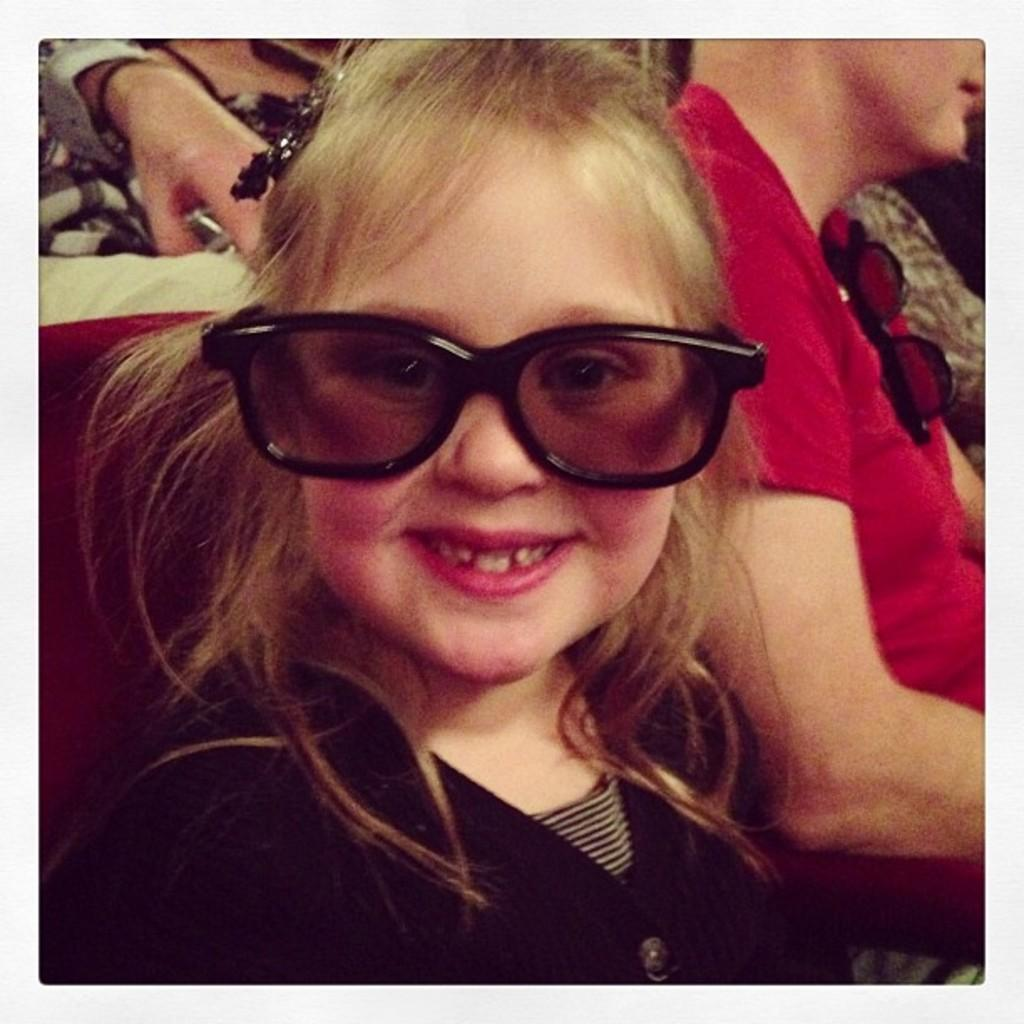Who is the main subject in the picture? There is a girl in the picture. What is the girl wearing in the picture? The girl is wearing goggles. What expression does the girl have in the picture? The girl is smiling. What can be seen in the background of the picture? There are people in the background of the picture. What type of beef is the girl eating in the picture? There is no beef present in the picture; the girl is wearing goggles and smiling. What is the weather like in the picture? The provided facts do not mention the weather, so it cannot be determined from the image. 